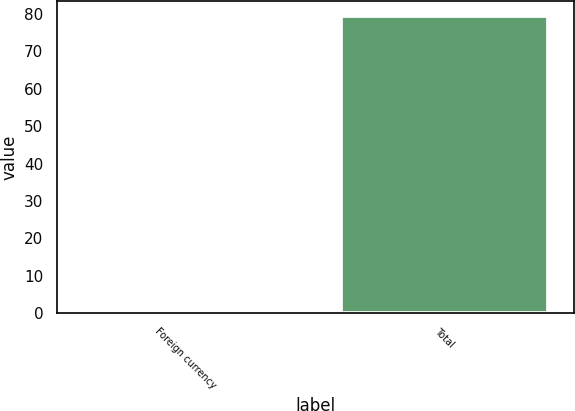Convert chart. <chart><loc_0><loc_0><loc_500><loc_500><bar_chart><fcel>Foreign currency<fcel>Total<nl><fcel>0.6<fcel>79.5<nl></chart> 